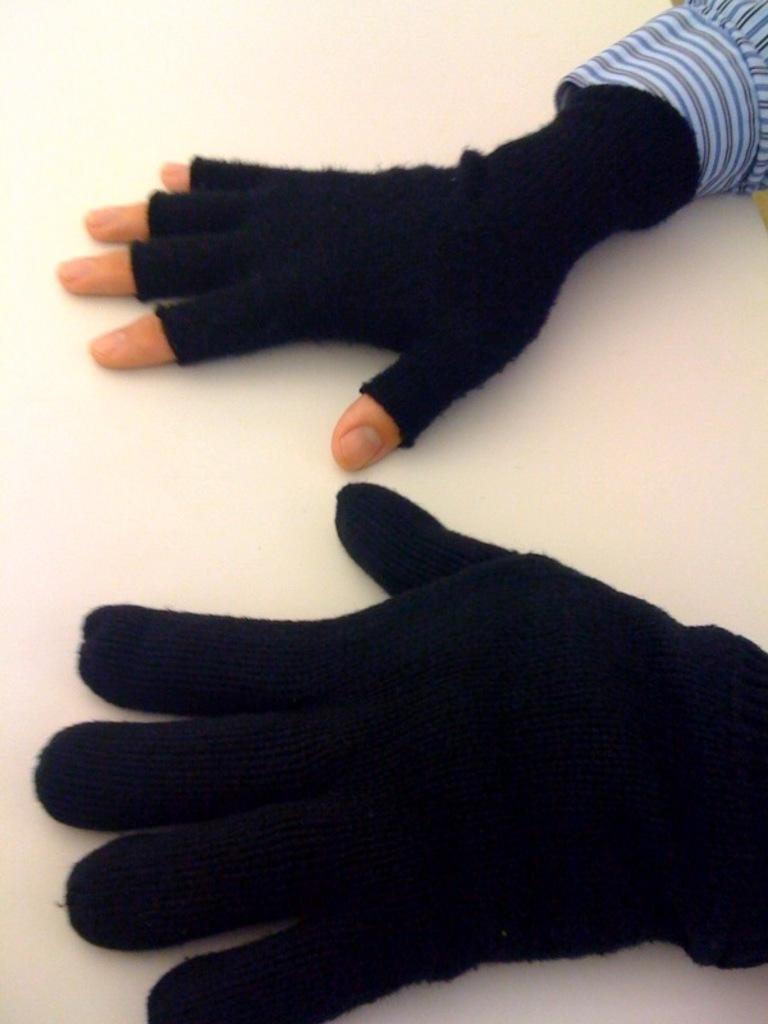What objects are present in the image? There are two hands with gloves in the image. What is the condition of the gloves? The gloves are half cut. Can you describe any other clothing item visible in the image? There is a cuff of a shirt visible in the top right corner of the image. What letter can be seen on the hand in the image? There is no letter visible on the hand in the image. What is the taste of the gloves in the image? Gloves do not have a taste, as they are not edible. 